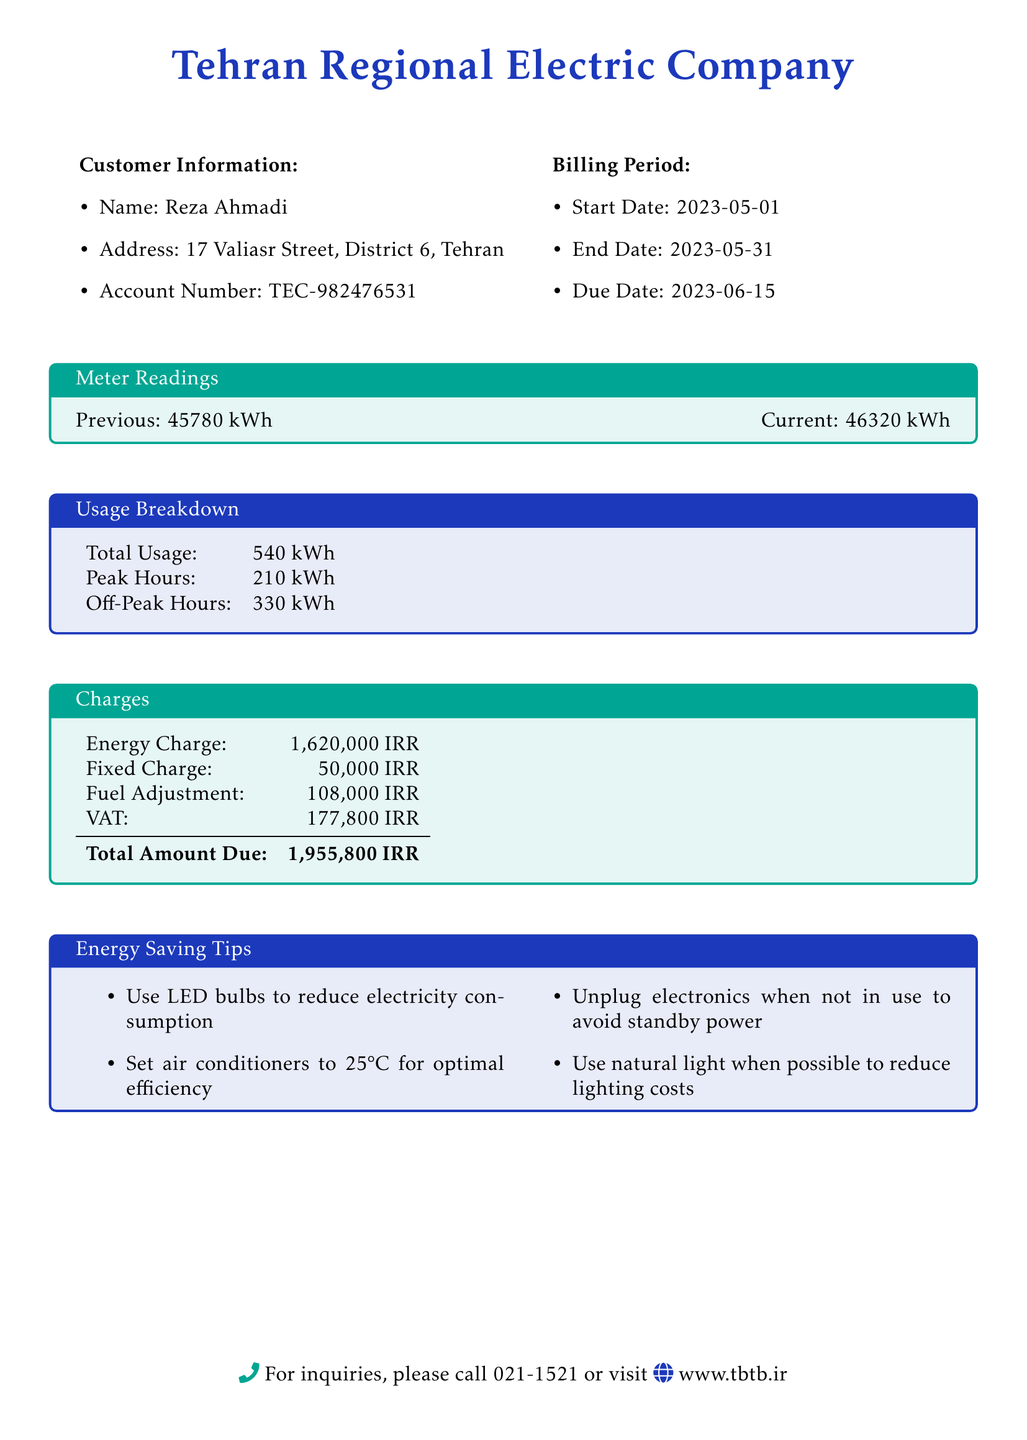What is the name of the customer? The document provides the customer's name as Reza Ahmadi.
Answer: Reza Ahmadi What is the total usage in kWh? The total usage is specified in the usage breakdown section of the document, which shows it as 540 kWh.
Answer: 540 kWh What is the due date of the bill? The due date is mentioned in the billing period section, listed as 2023-06-15.
Answer: 2023-06-15 What is the fixed charge amount? The fixed charge amount is detailed in the charges section, where it states 50,000 IRR.
Answer: 50,000 IRR How much is the VAT charged? The VAT charged is included in the charges section, which indicates it as 177,800 IRR.
Answer: 177,800 IRR What is the peak hours usage? The peak hours usage is provided in the usage breakdown section, stating it as 210 kWh.
Answer: 210 kWh What is the total amount due? The total amount due is clearly stated in the charges section of the bill, which amounts to 1,955,800 IRR.
Answer: 1,955,800 IRR What energy-saving tip suggests reducing lighting costs? One of the tips in the energy-saving section mentions using natural light to reduce lighting costs.
Answer: Use natural light What is the start date of the billing period? The start date is specified in the billing period section as 2023-05-01.
Answer: 2023-05-01 What is the recommended temperature setting for air conditioners? The energy-saving tips provide a recommendation to set air conditioners to 25°C for optimal efficiency.
Answer: 25°C 